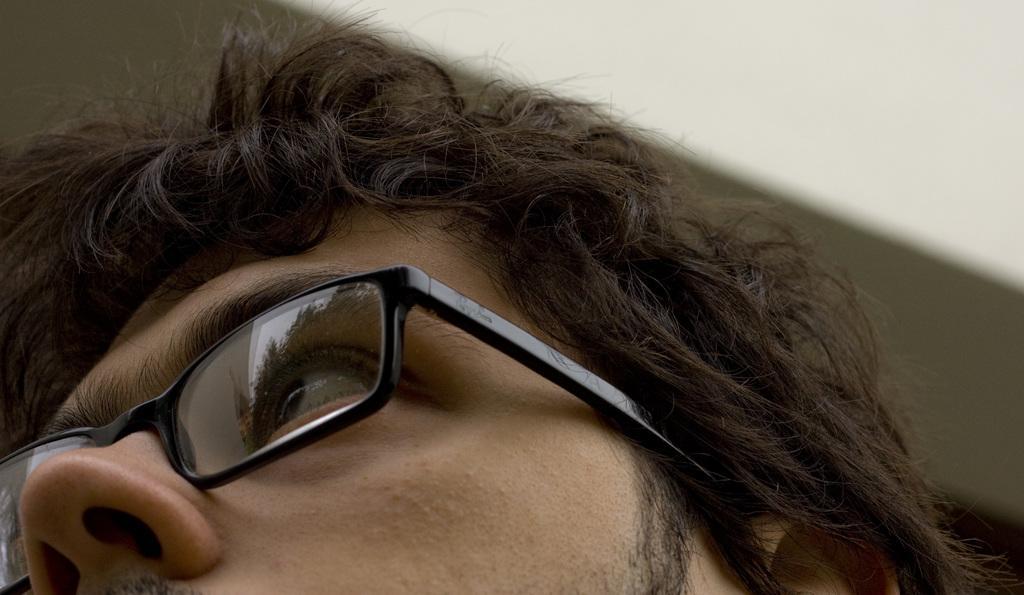Can you describe this image briefly? Here we can see face of a person which is truncated and he has spectacles. There is a blur background. 